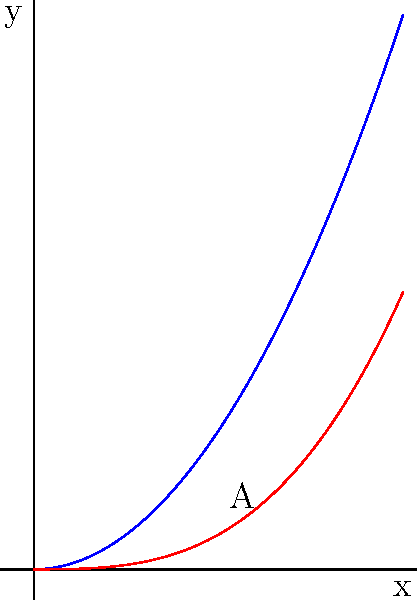As a software engineer working on optimizing memory allocation, you encounter a problem where the efficiency of your algorithm is represented by the area between two polynomial curves. The upper curve is given by $f(x) = x^2$ and the lower curve by $g(x) = \frac{x^3}{3}$. Calculate the area A between these curves from $x = 0$ to $x = 1$, which represents the performance gain of your optimization. Express your answer in terms of $\pi$ if necessary. To find the area between two curves, we need to:

1. Identify the limits of integration: $x = 0$ to $x = 1$

2. Set up the integral: 
   $$A = \int_{0}^{1} (f(x) - g(x)) dx = \int_{0}^{1} (x^2 - \frac{x^3}{3}) dx$$

3. Integrate:
   $$A = \int_{0}^{1} (x^2 - \frac{x^3}{3}) dx = [\frac{x^3}{3} - \frac{x^4}{12}]_{0}^{1}$$

4. Evaluate the integral:
   $$A = (\frac{1^3}{3} - \frac{1^4}{12}) - (0 - 0) = \frac{1}{3} - \frac{1}{12} = \frac{4}{12} - \frac{1}{12} = \frac{3}{12} = \frac{1}{4}$$

Therefore, the area between the curves from $x = 0$ to $x = 1$ is $\frac{1}{4}$ square units.
Answer: $\frac{1}{4}$ 